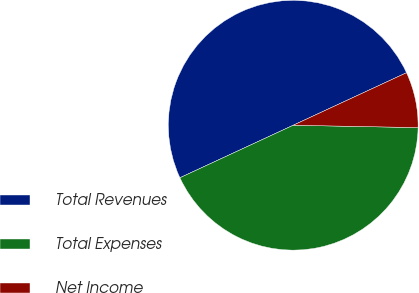Convert chart to OTSL. <chart><loc_0><loc_0><loc_500><loc_500><pie_chart><fcel>Total Revenues<fcel>Total Expenses<fcel>Net Income<nl><fcel>50.0%<fcel>42.79%<fcel>7.21%<nl></chart> 